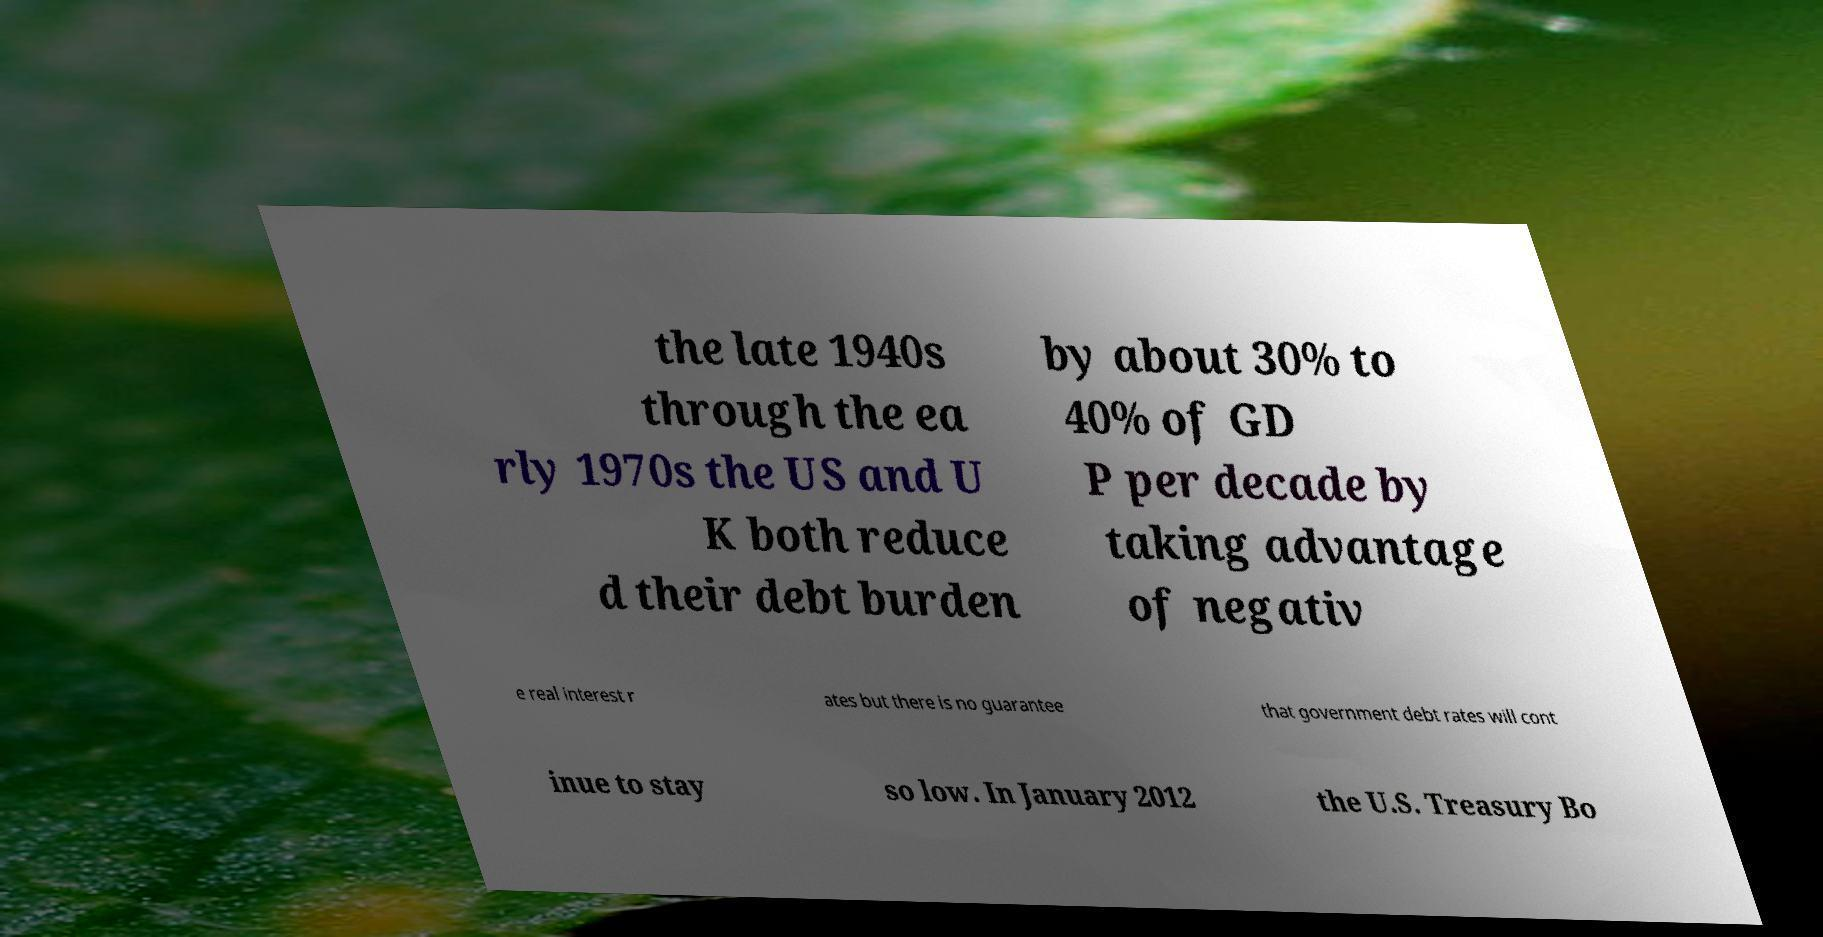Please read and relay the text visible in this image. What does it say? the late 1940s through the ea rly 1970s the US and U K both reduce d their debt burden by about 30% to 40% of GD P per decade by taking advantage of negativ e real interest r ates but there is no guarantee that government debt rates will cont inue to stay so low. In January 2012 the U.S. Treasury Bo 